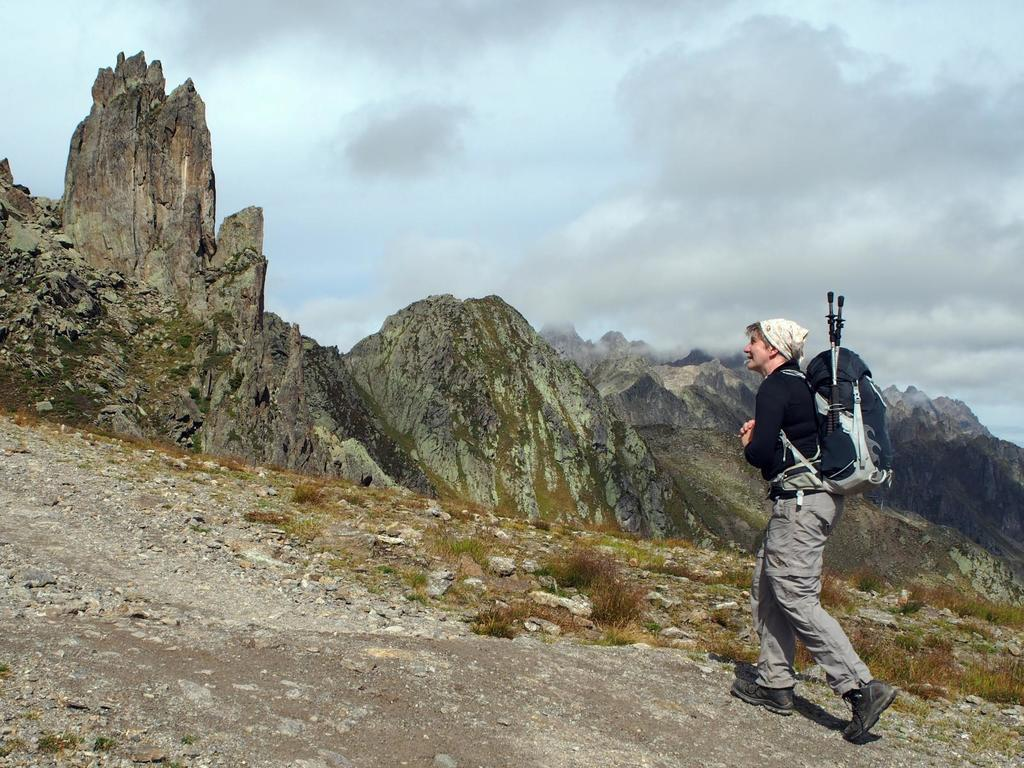What is the person in the image doing? The person is walking in the image. What is the person carrying while walking? The person is wearing a bag. What is in front of the person as they walk? There are stones and grass in front of the person. What type of landscape can be seen in the image? There are rock mountains in the image. What is visible at the top of the image? The sky is visible at the top of the image, and there are clouds in the sky. How many boats can be seen in the image? There are no boats present in the image. What type of bulb is used to light up the visitor's face in the image? There is no visitor or bulb present in the image. 